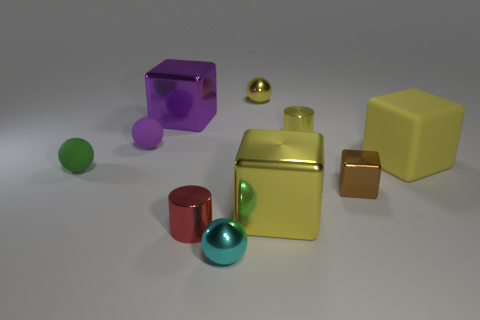Subtract all purple cubes. How many cubes are left? 3 Subtract all tiny metallic cubes. How many cubes are left? 3 Subtract 1 spheres. How many spheres are left? 3 Subtract all red balls. Subtract all blue cylinders. How many balls are left? 4 Subtract all cylinders. How many objects are left? 8 Subtract all small green matte spheres. Subtract all tiny red objects. How many objects are left? 8 Add 9 purple rubber things. How many purple rubber things are left? 10 Add 3 small brown metal blocks. How many small brown metal blocks exist? 4 Subtract 0 blue balls. How many objects are left? 10 